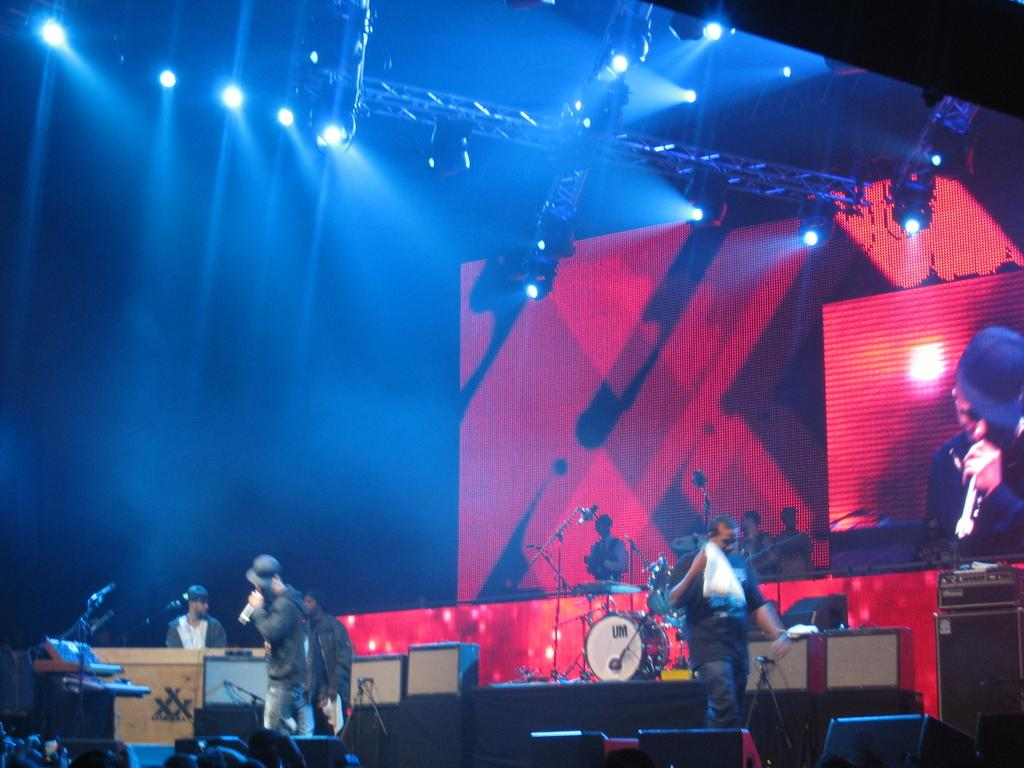What are the people in the image doing? The people in the image are playing musical instruments. What else can be seen in the image besides the people playing instruments? There is a screen visible in the image. Are there any other notable features in the image? Yes, there are lights on the roof in the image. Can you see a pig on the table in the image? There is no pig or table present in the image. What is the people's level of fear while playing the musical instruments? The image does not provide any information about the people's emotions or feelings, so we cannot determine their level of fear. 